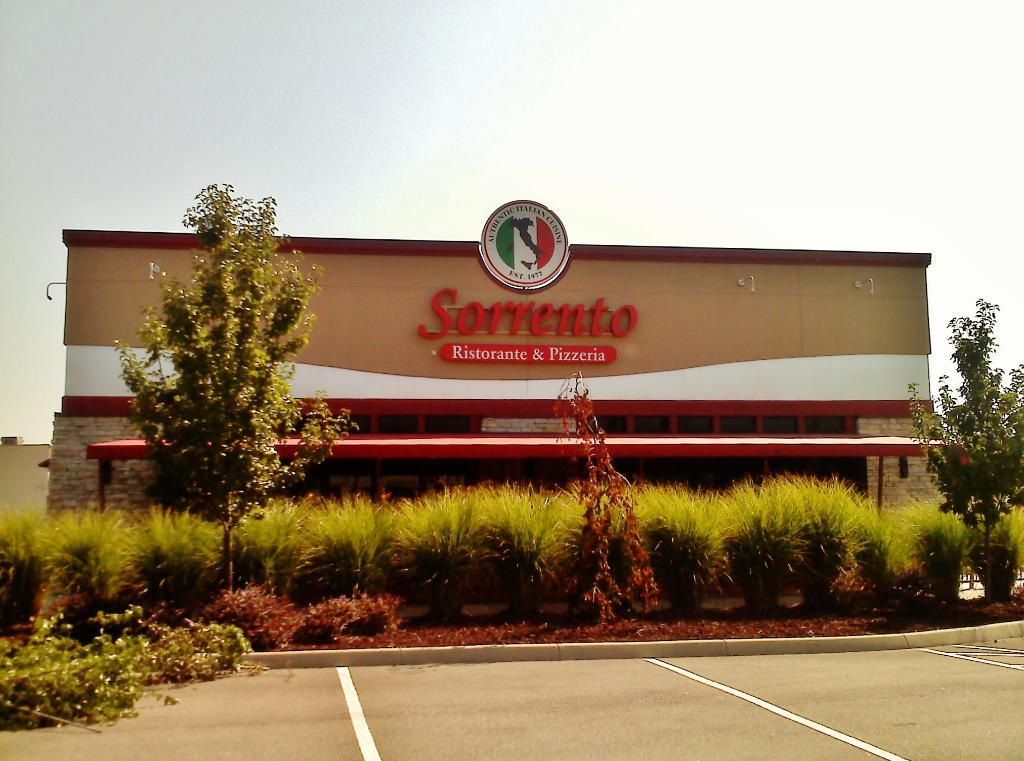What is featured on the wall in the center of the image? There is text and a logo on the wall in the center of the image. What can be seen at the bottom of the image? There is a road and plants at the bottom of the image, as well as a shed. What is visible at the top of the image? The sky is visible at the top of the image. What type of soda is being advertised by the text and logo on the wall? There is no soda being advertised in the image; the text and logo on the wall are not related to a soda product. What base material is used for the shed at the bottom of the image? The base material for the shed is not visible in the image, so it cannot be determined. 